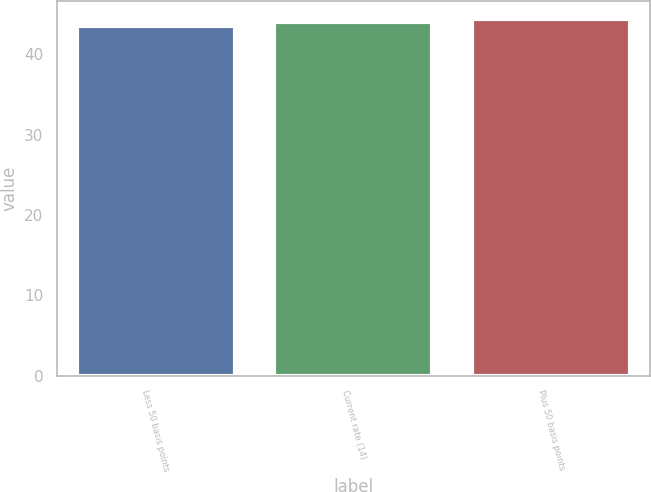Convert chart to OTSL. <chart><loc_0><loc_0><loc_500><loc_500><bar_chart><fcel>Less 50 basis points<fcel>Current rate (14)<fcel>Plus 50 basis points<nl><fcel>43.5<fcel>44<fcel>44.4<nl></chart> 